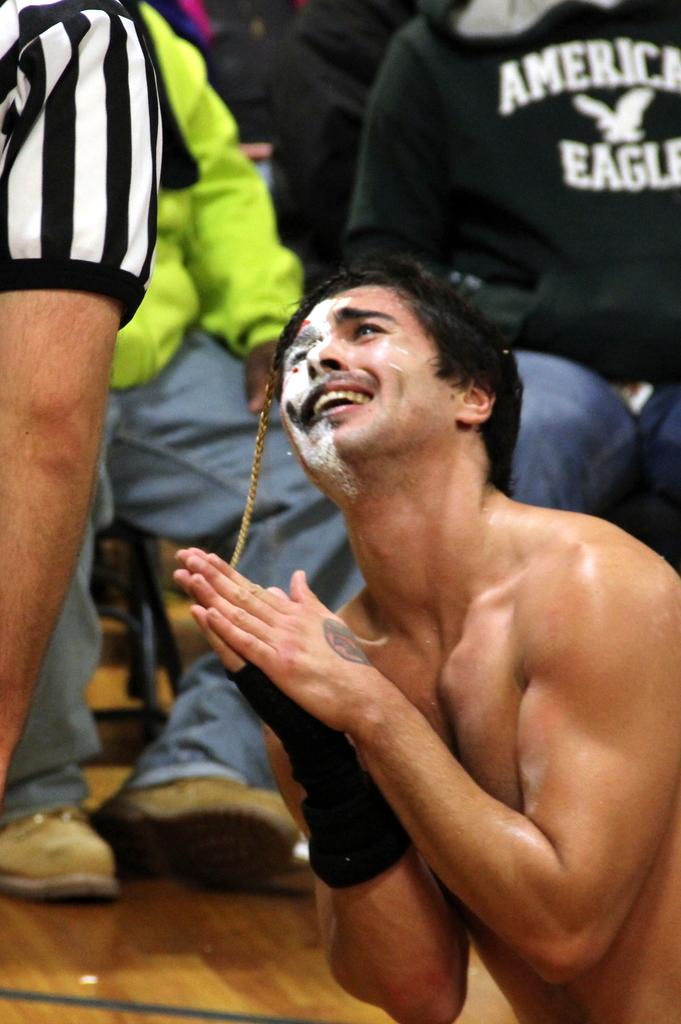What brand is the black sweat shirt?
Give a very brief answer. American eagle. 